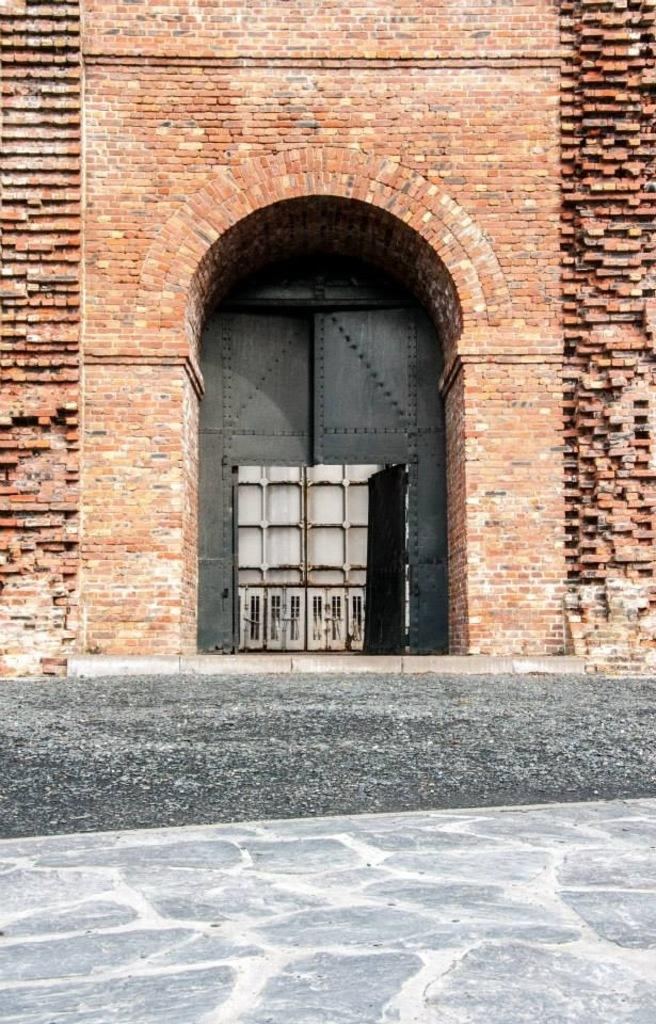What type of structure is in the picture? There is a building in the picture. What material is used for the building's wall? The building has a brick wall. Is there an entrance to the building? Yes, there is a door in the building. What can be seen on the floor near the building? There is soil on the floor. What type of skin condition is visible on the building's wall in the image? There is no skin condition visible on the building's wall in the image; it is made of brick. What stage of development is the building in the image? The image does not provide information about the building's development stage. 